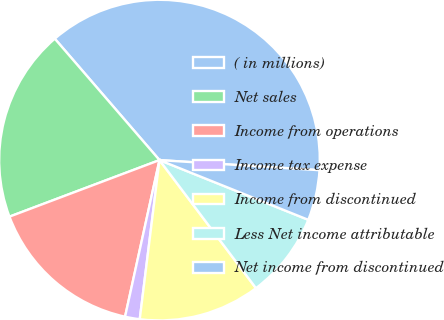<chart> <loc_0><loc_0><loc_500><loc_500><pie_chart><fcel>( in millions)<fcel>Net sales<fcel>Income from operations<fcel>Income tax expense<fcel>Income from discontinued<fcel>Less Net income attributable<fcel>Net income from discontinued<nl><fcel>37.33%<fcel>19.41%<fcel>15.82%<fcel>1.48%<fcel>12.24%<fcel>8.65%<fcel>5.07%<nl></chart> 